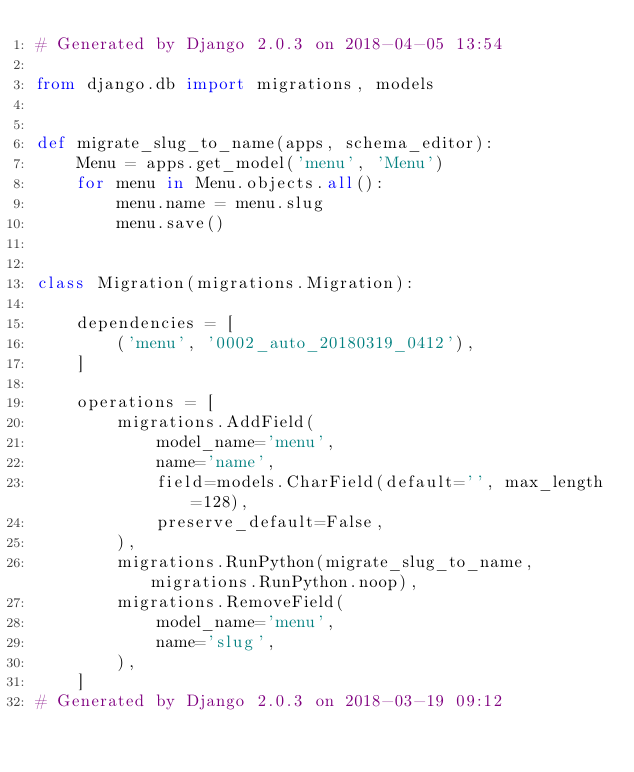<code> <loc_0><loc_0><loc_500><loc_500><_Python_># Generated by Django 2.0.3 on 2018-04-05 13:54

from django.db import migrations, models


def migrate_slug_to_name(apps, schema_editor):
    Menu = apps.get_model('menu', 'Menu')
    for menu in Menu.objects.all():
        menu.name = menu.slug
        menu.save()


class Migration(migrations.Migration):

    dependencies = [
        ('menu', '0002_auto_20180319_0412'),
    ]

    operations = [
        migrations.AddField(
            model_name='menu',
            name='name',
            field=models.CharField(default='', max_length=128),
            preserve_default=False,
        ),
        migrations.RunPython(migrate_slug_to_name, migrations.RunPython.noop),
        migrations.RemoveField(
            model_name='menu',
            name='slug',
        ),
    ]
# Generated by Django 2.0.3 on 2018-03-19 09:12
</code> 